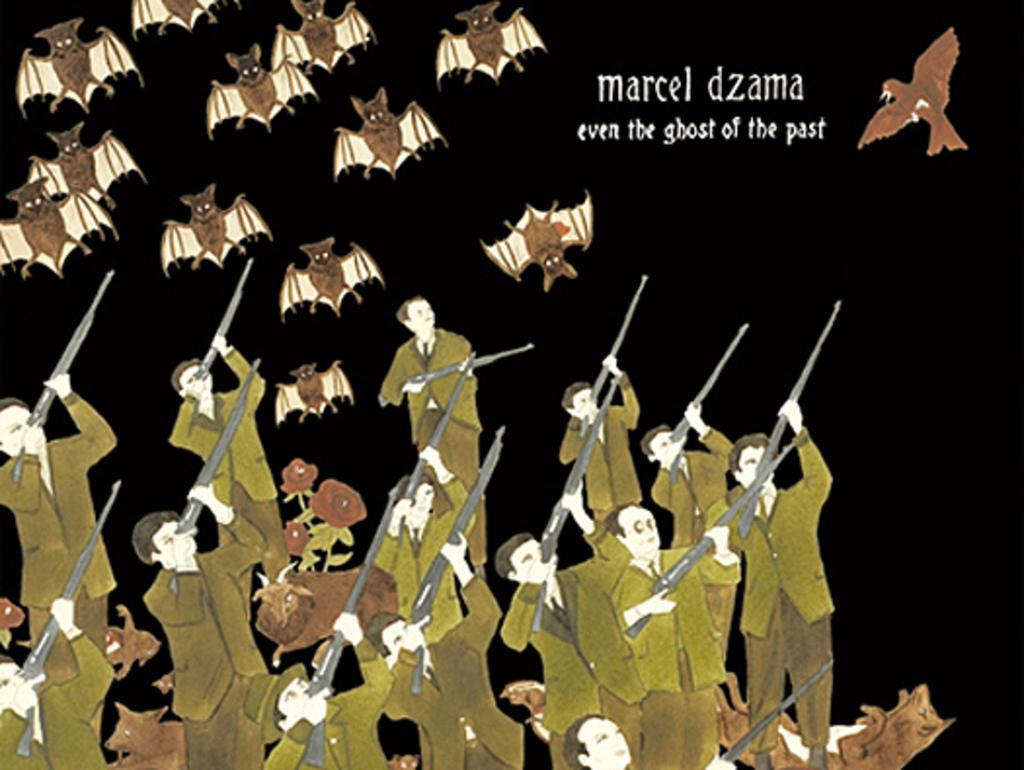In one or two sentences, can you explain what this image depicts? In the image we can see this is an animated picture. There are people wearing clothes and holding a rifle in hand. There are many bats and this is a text. 